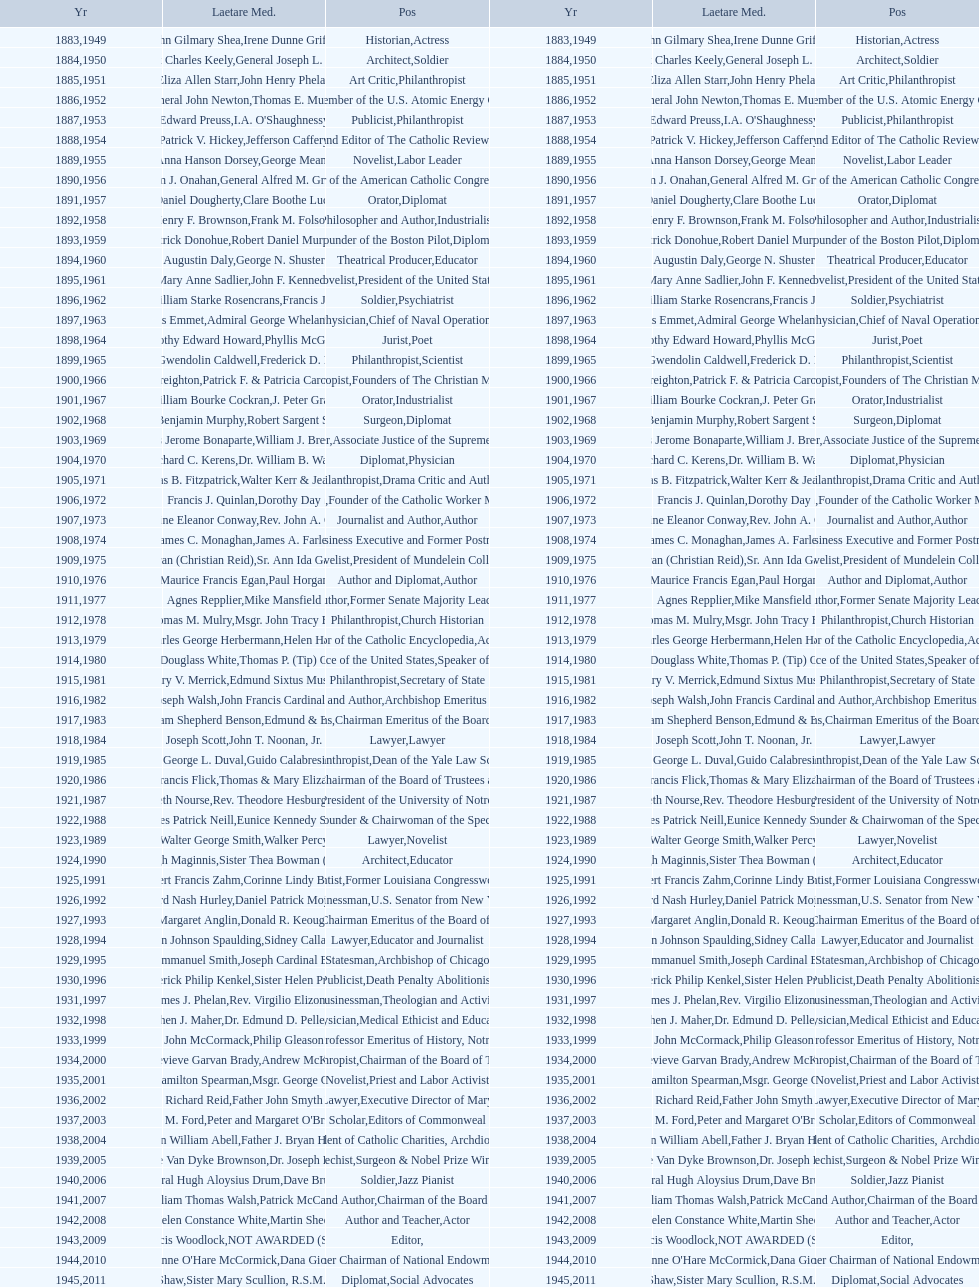What are the number of laetare medalist that held a diplomat position? 8. 